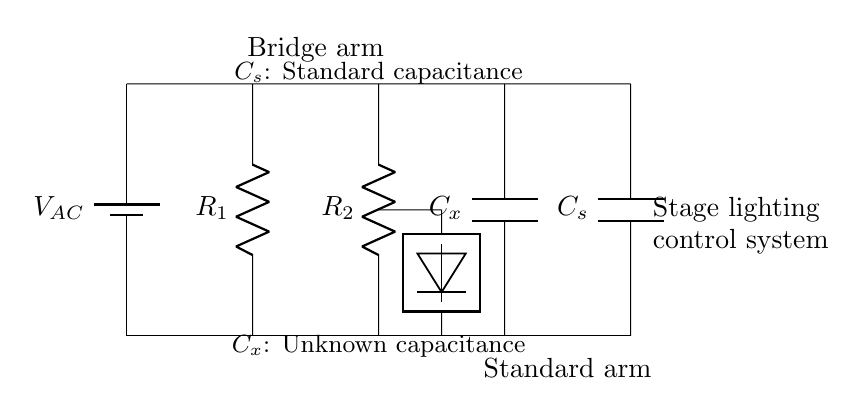What is the voltage source in this circuit? The circuit diagram indicates that there is a voltage source labeled VAC connected between the two horizontal lines, supplying alternating current.
Answer: VAC What components are in the left arm of the bridge? The left arm of the bridge contains a resistor labeled R1 connected in series with another resistor labeled R2, indicating that both are part of the parallel arrangement of the bridge.
Answer: R1 and R2 How is the unknown capacitance denoted in the circuit? In the diagram, the unknown capacitance is represented by Cx, which is placed in one of the arms of the bridge.
Answer: Cx What is the function of the detector in the circuit? The detector is used to measure the balance condition of the bridge by checking the voltage across two points, indicating whether the bridge is balanced or not.
Answer: Measurement What relationship exists between Cx and Cs in this bridge circuit? In this AC bridge circuit, the relationship between the unknown capacitance Cx and the standard capacitance Cs can be established when the bridge is balanced, allowing capacitances to be compared directly.
Answer: Capacitance comparison How is the standard capacitance labeled? The standard capacitance in the circuit is identified by the label Cs, which is connected in parallel with the unknown capacitance at the other side of the bridge.
Answer: Cs What is indicated by the term "bridge arm" in the diagram? The term "bridge arm" refers to the sections of the circuit connected in such a way that they work together to measure capacitance, specifically through the arrangement involving R1, R2, and Cx.
Answer: Sections for capacitance measurement 